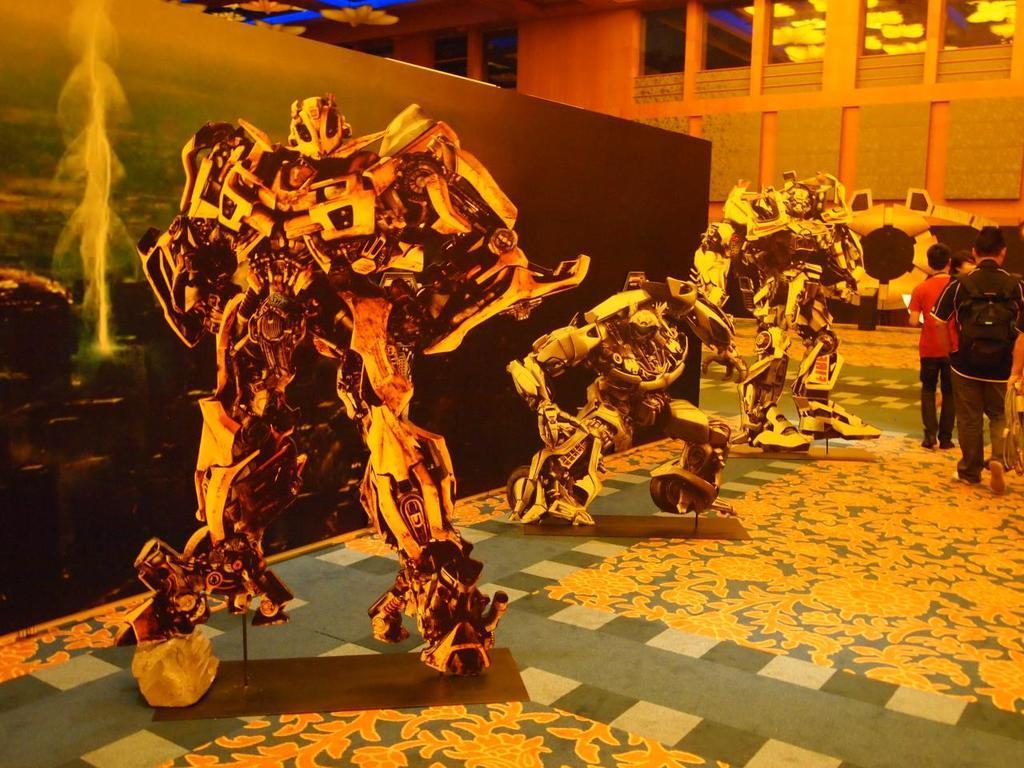Could you give a brief overview of what you see in this image? On the left side, there are animated images of a robots arranged on the floor. Beside them, there is a wall poster. On the right side, there are persons walking on the floor. In the background, there are glass windows and there is a wall. 